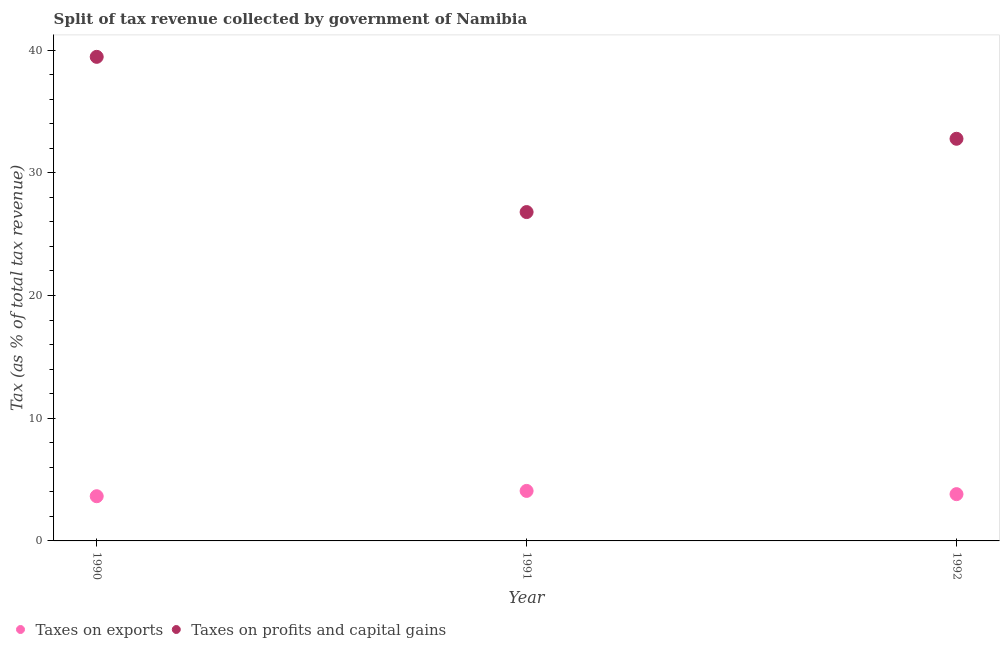How many different coloured dotlines are there?
Keep it short and to the point. 2. What is the percentage of revenue obtained from taxes on profits and capital gains in 1991?
Provide a short and direct response. 26.8. Across all years, what is the maximum percentage of revenue obtained from taxes on profits and capital gains?
Make the answer very short. 39.45. Across all years, what is the minimum percentage of revenue obtained from taxes on exports?
Offer a very short reply. 3.64. In which year was the percentage of revenue obtained from taxes on profits and capital gains maximum?
Your response must be concise. 1990. In which year was the percentage of revenue obtained from taxes on exports minimum?
Make the answer very short. 1990. What is the total percentage of revenue obtained from taxes on profits and capital gains in the graph?
Provide a short and direct response. 99.01. What is the difference between the percentage of revenue obtained from taxes on profits and capital gains in 1990 and that in 1991?
Offer a very short reply. 12.65. What is the difference between the percentage of revenue obtained from taxes on profits and capital gains in 1992 and the percentage of revenue obtained from taxes on exports in 1991?
Offer a very short reply. 28.7. What is the average percentage of revenue obtained from taxes on profits and capital gains per year?
Ensure brevity in your answer.  33. In the year 1990, what is the difference between the percentage of revenue obtained from taxes on profits and capital gains and percentage of revenue obtained from taxes on exports?
Offer a terse response. 35.8. What is the ratio of the percentage of revenue obtained from taxes on profits and capital gains in 1990 to that in 1992?
Your response must be concise. 1.2. What is the difference between the highest and the second highest percentage of revenue obtained from taxes on profits and capital gains?
Your answer should be compact. 6.68. What is the difference between the highest and the lowest percentage of revenue obtained from taxes on profits and capital gains?
Your answer should be very brief. 12.65. Is the sum of the percentage of revenue obtained from taxes on exports in 1991 and 1992 greater than the maximum percentage of revenue obtained from taxes on profits and capital gains across all years?
Offer a terse response. No. Does the percentage of revenue obtained from taxes on exports monotonically increase over the years?
Give a very brief answer. No. Is the percentage of revenue obtained from taxes on profits and capital gains strictly less than the percentage of revenue obtained from taxes on exports over the years?
Give a very brief answer. No. How many years are there in the graph?
Your answer should be compact. 3. Does the graph contain any zero values?
Ensure brevity in your answer.  No. Does the graph contain grids?
Your answer should be very brief. No. What is the title of the graph?
Your answer should be compact. Split of tax revenue collected by government of Namibia. What is the label or title of the X-axis?
Your answer should be compact. Year. What is the label or title of the Y-axis?
Offer a terse response. Tax (as % of total tax revenue). What is the Tax (as % of total tax revenue) of Taxes on exports in 1990?
Your answer should be very brief. 3.64. What is the Tax (as % of total tax revenue) of Taxes on profits and capital gains in 1990?
Provide a succinct answer. 39.45. What is the Tax (as % of total tax revenue) in Taxes on exports in 1991?
Your response must be concise. 4.07. What is the Tax (as % of total tax revenue) in Taxes on profits and capital gains in 1991?
Keep it short and to the point. 26.8. What is the Tax (as % of total tax revenue) in Taxes on exports in 1992?
Ensure brevity in your answer.  3.81. What is the Tax (as % of total tax revenue) of Taxes on profits and capital gains in 1992?
Provide a succinct answer. 32.77. Across all years, what is the maximum Tax (as % of total tax revenue) in Taxes on exports?
Provide a succinct answer. 4.07. Across all years, what is the maximum Tax (as % of total tax revenue) of Taxes on profits and capital gains?
Your answer should be compact. 39.45. Across all years, what is the minimum Tax (as % of total tax revenue) in Taxes on exports?
Give a very brief answer. 3.64. Across all years, what is the minimum Tax (as % of total tax revenue) of Taxes on profits and capital gains?
Provide a short and direct response. 26.8. What is the total Tax (as % of total tax revenue) in Taxes on exports in the graph?
Your response must be concise. 11.53. What is the total Tax (as % of total tax revenue) of Taxes on profits and capital gains in the graph?
Provide a short and direct response. 99.01. What is the difference between the Tax (as % of total tax revenue) of Taxes on exports in 1990 and that in 1991?
Provide a short and direct response. -0.43. What is the difference between the Tax (as % of total tax revenue) of Taxes on profits and capital gains in 1990 and that in 1991?
Offer a very short reply. 12.65. What is the difference between the Tax (as % of total tax revenue) in Taxes on exports in 1990 and that in 1992?
Give a very brief answer. -0.17. What is the difference between the Tax (as % of total tax revenue) in Taxes on profits and capital gains in 1990 and that in 1992?
Ensure brevity in your answer.  6.68. What is the difference between the Tax (as % of total tax revenue) of Taxes on exports in 1991 and that in 1992?
Offer a terse response. 0.26. What is the difference between the Tax (as % of total tax revenue) in Taxes on profits and capital gains in 1991 and that in 1992?
Provide a short and direct response. -5.97. What is the difference between the Tax (as % of total tax revenue) of Taxes on exports in 1990 and the Tax (as % of total tax revenue) of Taxes on profits and capital gains in 1991?
Offer a very short reply. -23.16. What is the difference between the Tax (as % of total tax revenue) of Taxes on exports in 1990 and the Tax (as % of total tax revenue) of Taxes on profits and capital gains in 1992?
Your response must be concise. -29.13. What is the difference between the Tax (as % of total tax revenue) in Taxes on exports in 1991 and the Tax (as % of total tax revenue) in Taxes on profits and capital gains in 1992?
Your response must be concise. -28.7. What is the average Tax (as % of total tax revenue) in Taxes on exports per year?
Offer a very short reply. 3.84. What is the average Tax (as % of total tax revenue) in Taxes on profits and capital gains per year?
Your answer should be compact. 33. In the year 1990, what is the difference between the Tax (as % of total tax revenue) of Taxes on exports and Tax (as % of total tax revenue) of Taxes on profits and capital gains?
Offer a very short reply. -35.8. In the year 1991, what is the difference between the Tax (as % of total tax revenue) in Taxes on exports and Tax (as % of total tax revenue) in Taxes on profits and capital gains?
Your answer should be very brief. -22.72. In the year 1992, what is the difference between the Tax (as % of total tax revenue) in Taxes on exports and Tax (as % of total tax revenue) in Taxes on profits and capital gains?
Provide a succinct answer. -28.96. What is the ratio of the Tax (as % of total tax revenue) in Taxes on exports in 1990 to that in 1991?
Your response must be concise. 0.89. What is the ratio of the Tax (as % of total tax revenue) in Taxes on profits and capital gains in 1990 to that in 1991?
Offer a terse response. 1.47. What is the ratio of the Tax (as % of total tax revenue) of Taxes on exports in 1990 to that in 1992?
Make the answer very short. 0.96. What is the ratio of the Tax (as % of total tax revenue) in Taxes on profits and capital gains in 1990 to that in 1992?
Provide a short and direct response. 1.2. What is the ratio of the Tax (as % of total tax revenue) in Taxes on exports in 1991 to that in 1992?
Your answer should be very brief. 1.07. What is the ratio of the Tax (as % of total tax revenue) in Taxes on profits and capital gains in 1991 to that in 1992?
Ensure brevity in your answer.  0.82. What is the difference between the highest and the second highest Tax (as % of total tax revenue) of Taxes on exports?
Provide a succinct answer. 0.26. What is the difference between the highest and the second highest Tax (as % of total tax revenue) of Taxes on profits and capital gains?
Provide a succinct answer. 6.68. What is the difference between the highest and the lowest Tax (as % of total tax revenue) in Taxes on exports?
Ensure brevity in your answer.  0.43. What is the difference between the highest and the lowest Tax (as % of total tax revenue) of Taxes on profits and capital gains?
Ensure brevity in your answer.  12.65. 